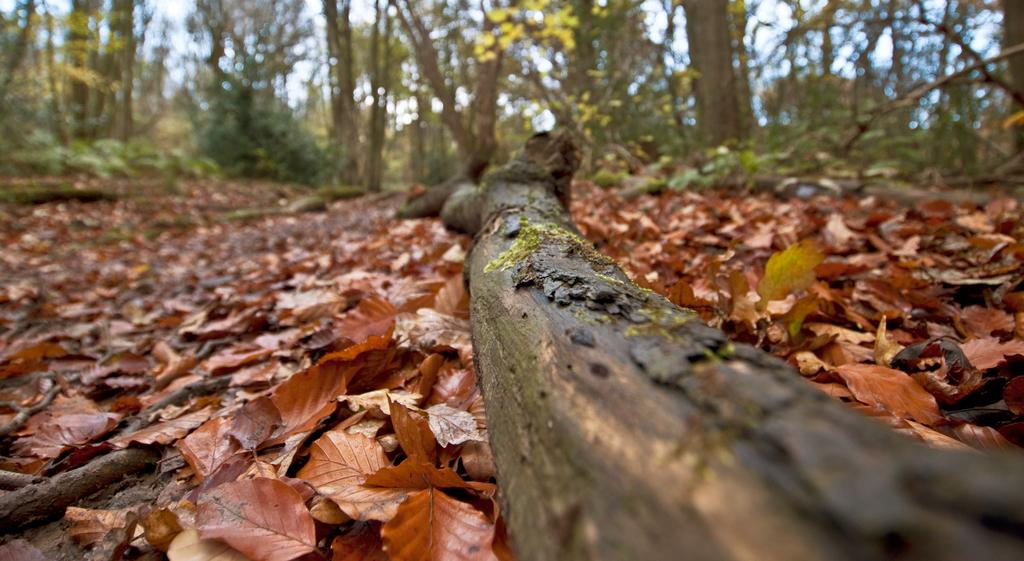What is the main object in the image? There is a wooden log in the image. What can be seen on the ground in the image? Dried leaves are present on the ground in the image. What is visible in the background of the image? There are trees and the sky visible in the background of the image. What type of fuel is being used by the scale in the image? There is no scale or fuel present in the image. How does the wooden log express disgust in the image? The wooden log is an inanimate object and cannot express emotions like disgust. 